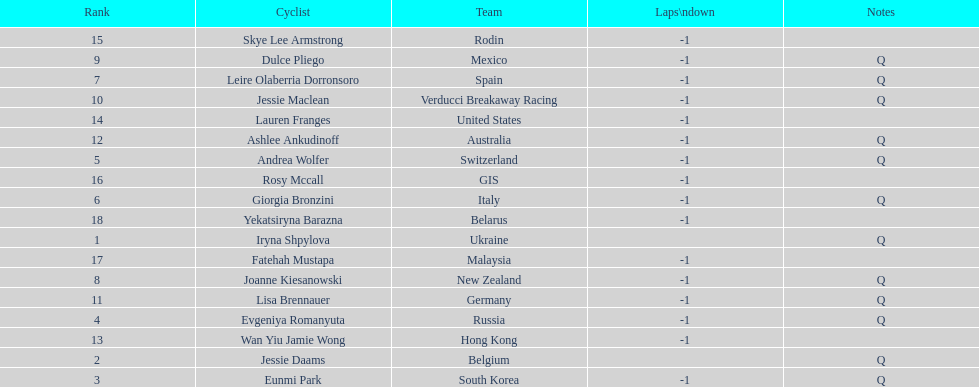How many consecutive notes are there? 12. 